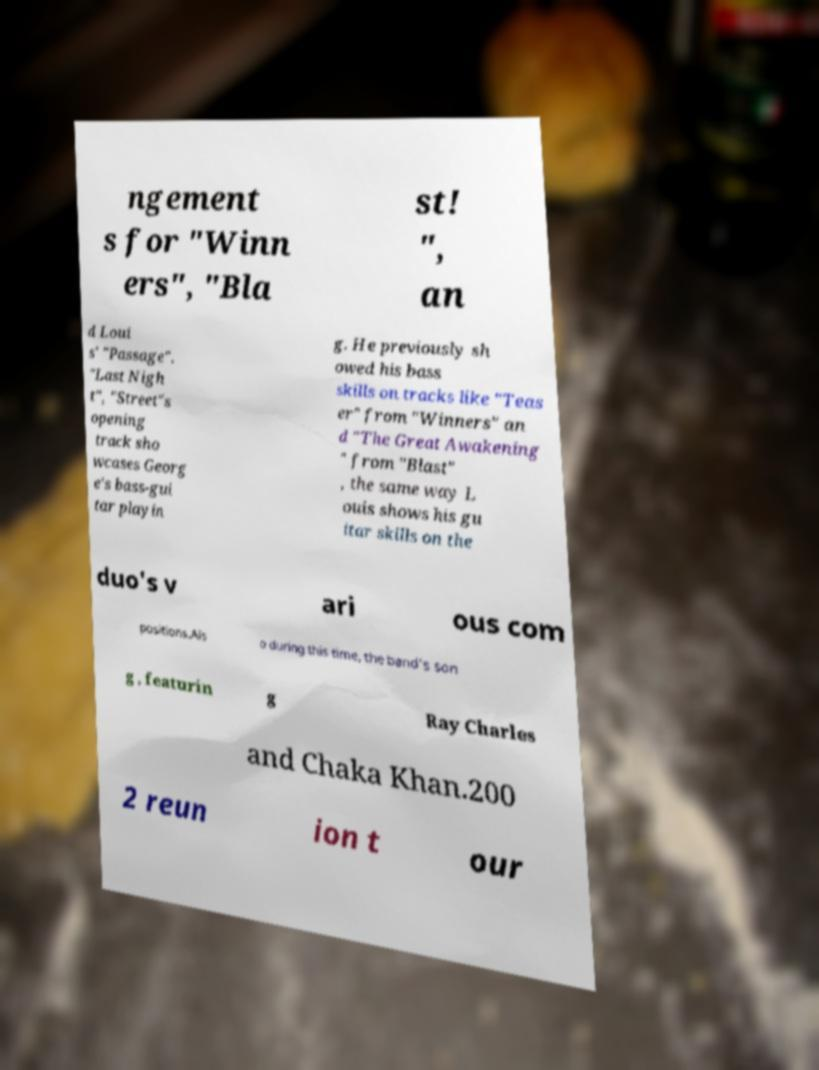Please identify and transcribe the text found in this image. ngement s for "Winn ers", "Bla st! ", an d Loui s' "Passage". "Last Nigh t", "Street"s opening track sho wcases Georg e's bass-gui tar playin g. He previously sh owed his bass skills on tracks like "Teas er" from "Winners" an d "The Great Awakening " from "Blast" , the same way L ouis shows his gu itar skills on the duo's v ari ous com positions.Als o during this time, the band's son g , featurin g Ray Charles and Chaka Khan.200 2 reun ion t our 